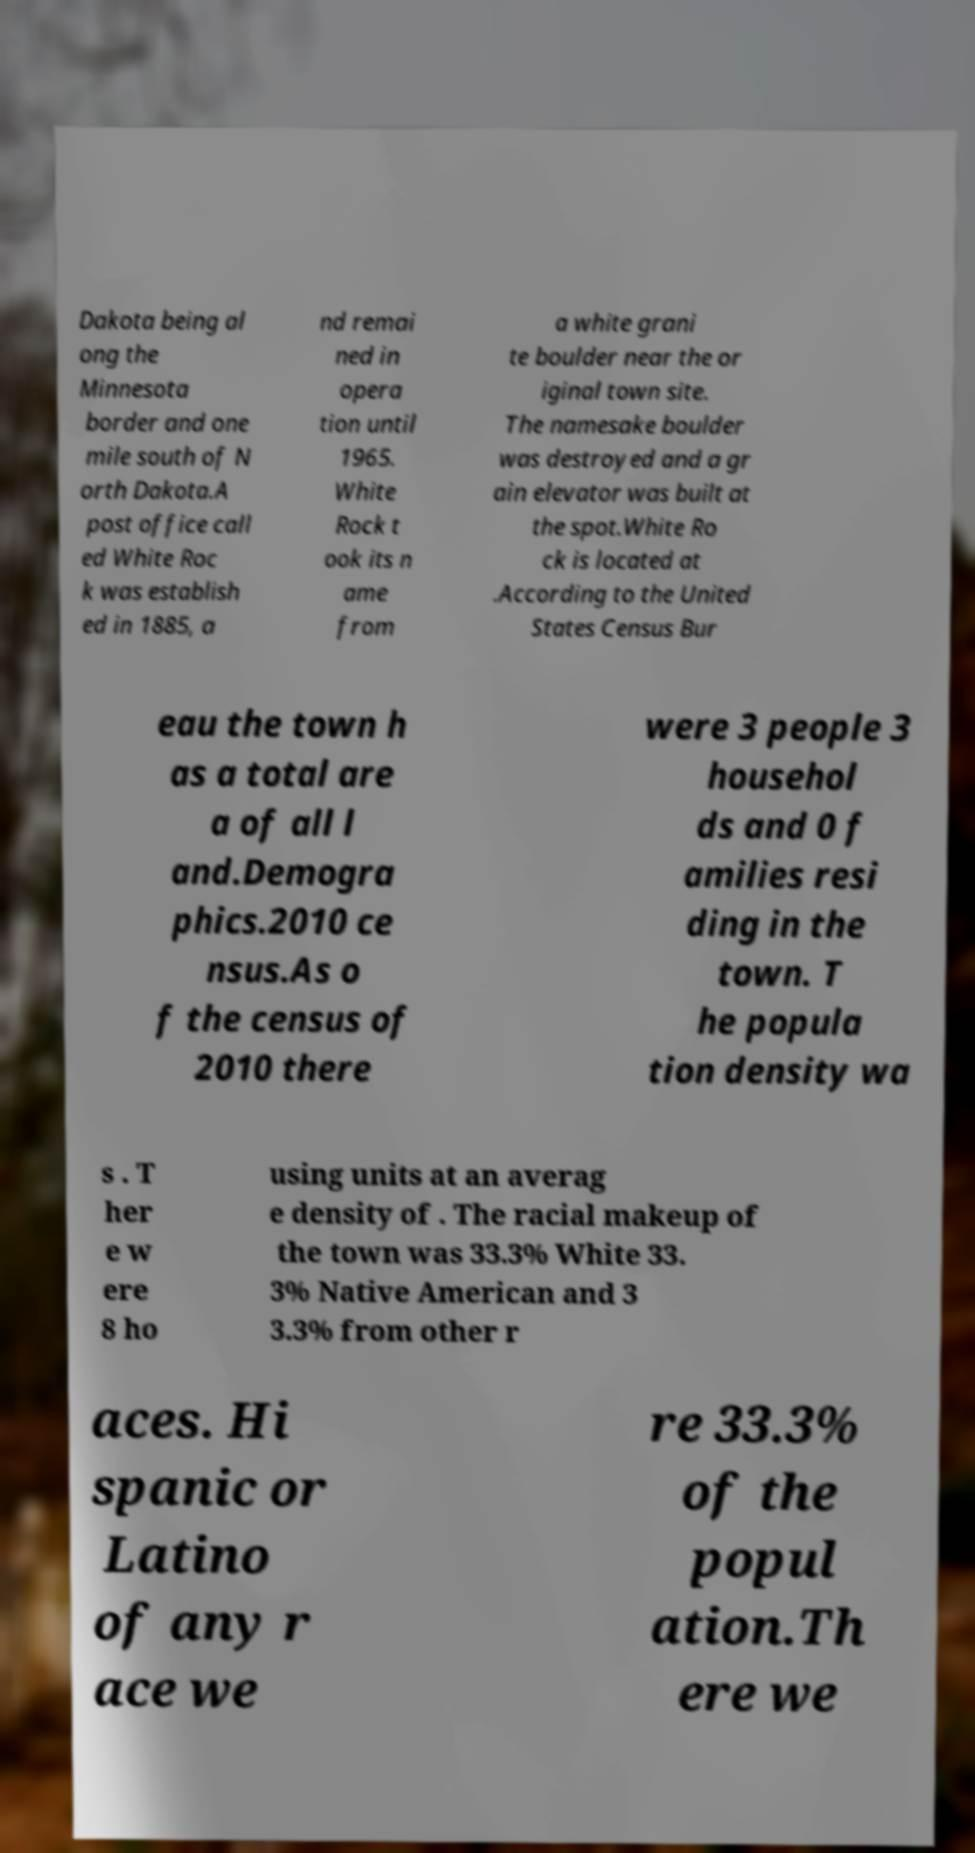For documentation purposes, I need the text within this image transcribed. Could you provide that? Dakota being al ong the Minnesota border and one mile south of N orth Dakota.A post office call ed White Roc k was establish ed in 1885, a nd remai ned in opera tion until 1965. White Rock t ook its n ame from a white grani te boulder near the or iginal town site. The namesake boulder was destroyed and a gr ain elevator was built at the spot.White Ro ck is located at .According to the United States Census Bur eau the town h as a total are a of all l and.Demogra phics.2010 ce nsus.As o f the census of 2010 there were 3 people 3 househol ds and 0 f amilies resi ding in the town. T he popula tion density wa s . T her e w ere 8 ho using units at an averag e density of . The racial makeup of the town was 33.3% White 33. 3% Native American and 3 3.3% from other r aces. Hi spanic or Latino of any r ace we re 33.3% of the popul ation.Th ere we 